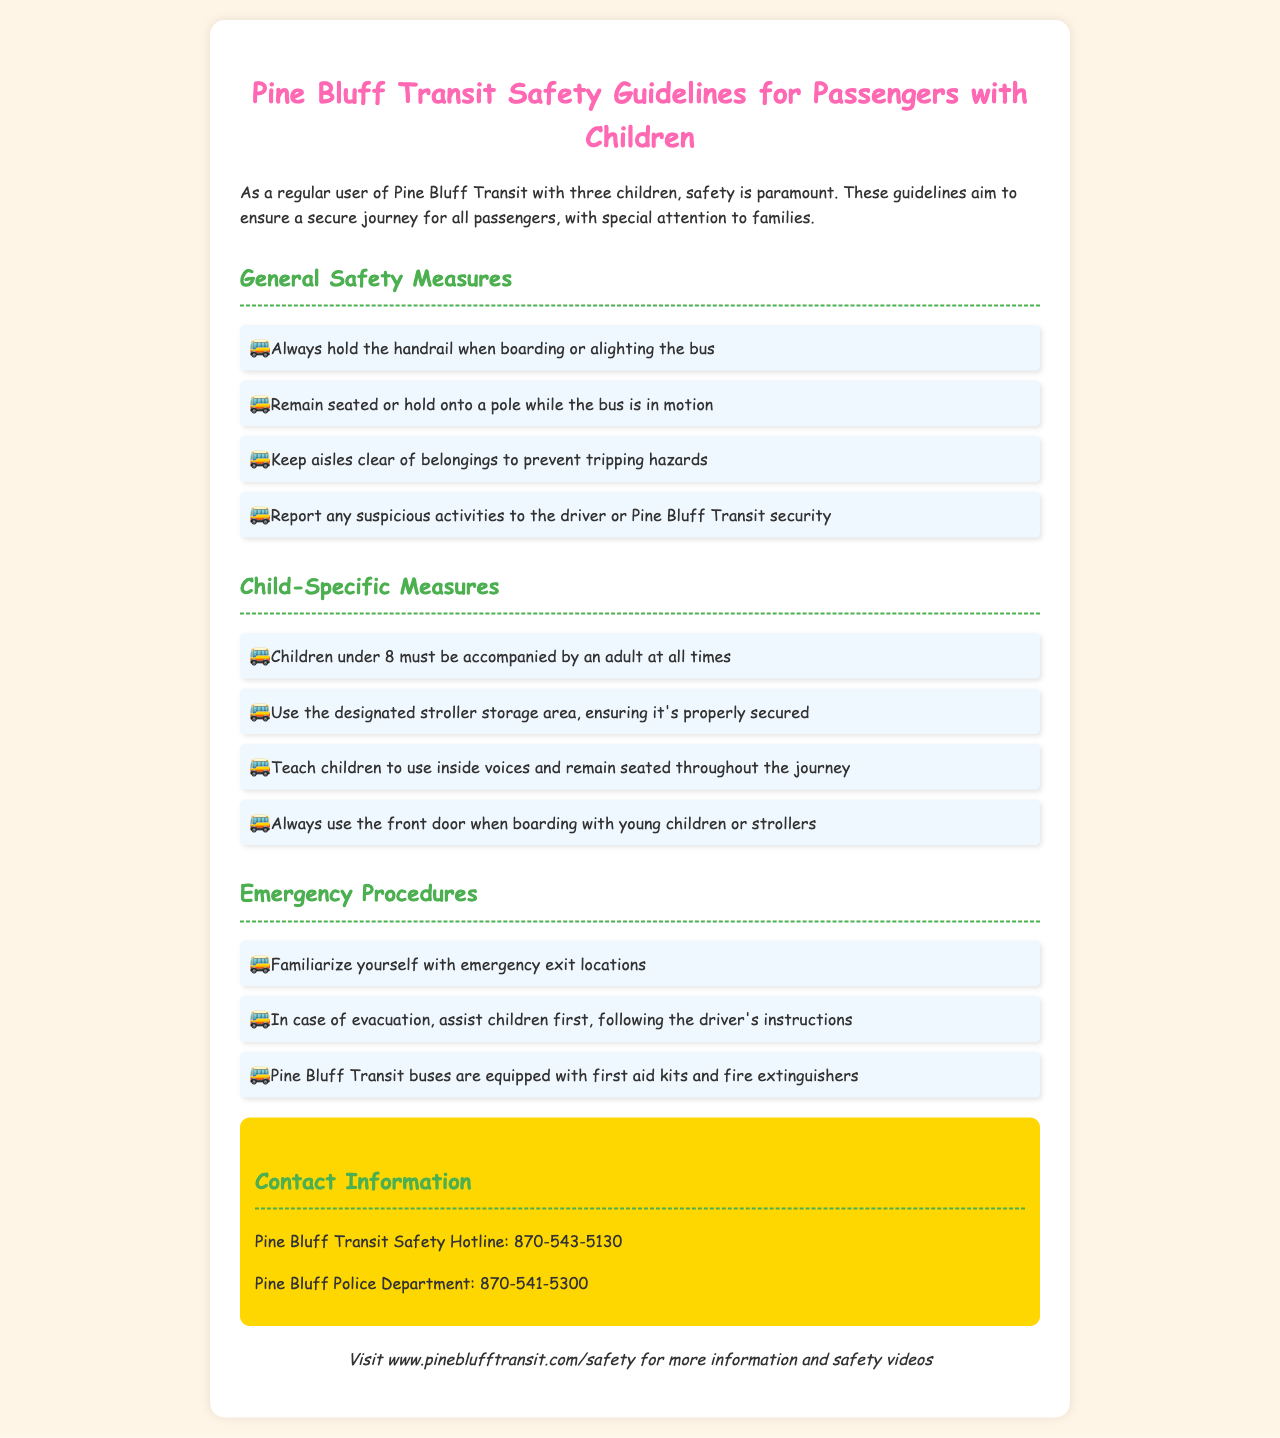What is the age limit for children to be accompanied by an adult? The policy states that children under 8 must be accompanied by an adult at all times.
Answer: under 8 What should passengers do if they notice suspicious activities? Passengers should report any suspicious activities to the driver or Pine Bluff Transit security.
Answer: report to the driver or security What is provided on Pine Bluff Transit buses for emergencies? The buses are equipped with first aid kits and fire extinguishers.
Answer: first aid kits and fire extinguishers What must be done with strollers when boarding the bus? The designated stroller storage area must be used, ensuring it's properly secured.
Answer: use designated stroller storage area What is the recommended action during an evacuation? Passengers should assist children first, following the driver's instructions.
Answer: assist children first How should children behave on the bus? Children should use inside voices and remain seated throughout the journey.
Answer: use inside voices, remain seated What is the contact number for Pine Bluff Transit Safety Hotline? The document provides the Pine Bluff Transit Safety Hotline number as 870-543-5130.
Answer: 870-543-5130 Which door should be used when boarding with young children or strollers? Passengers should always use the front door when boarding with young children or strollers.
Answer: front door 